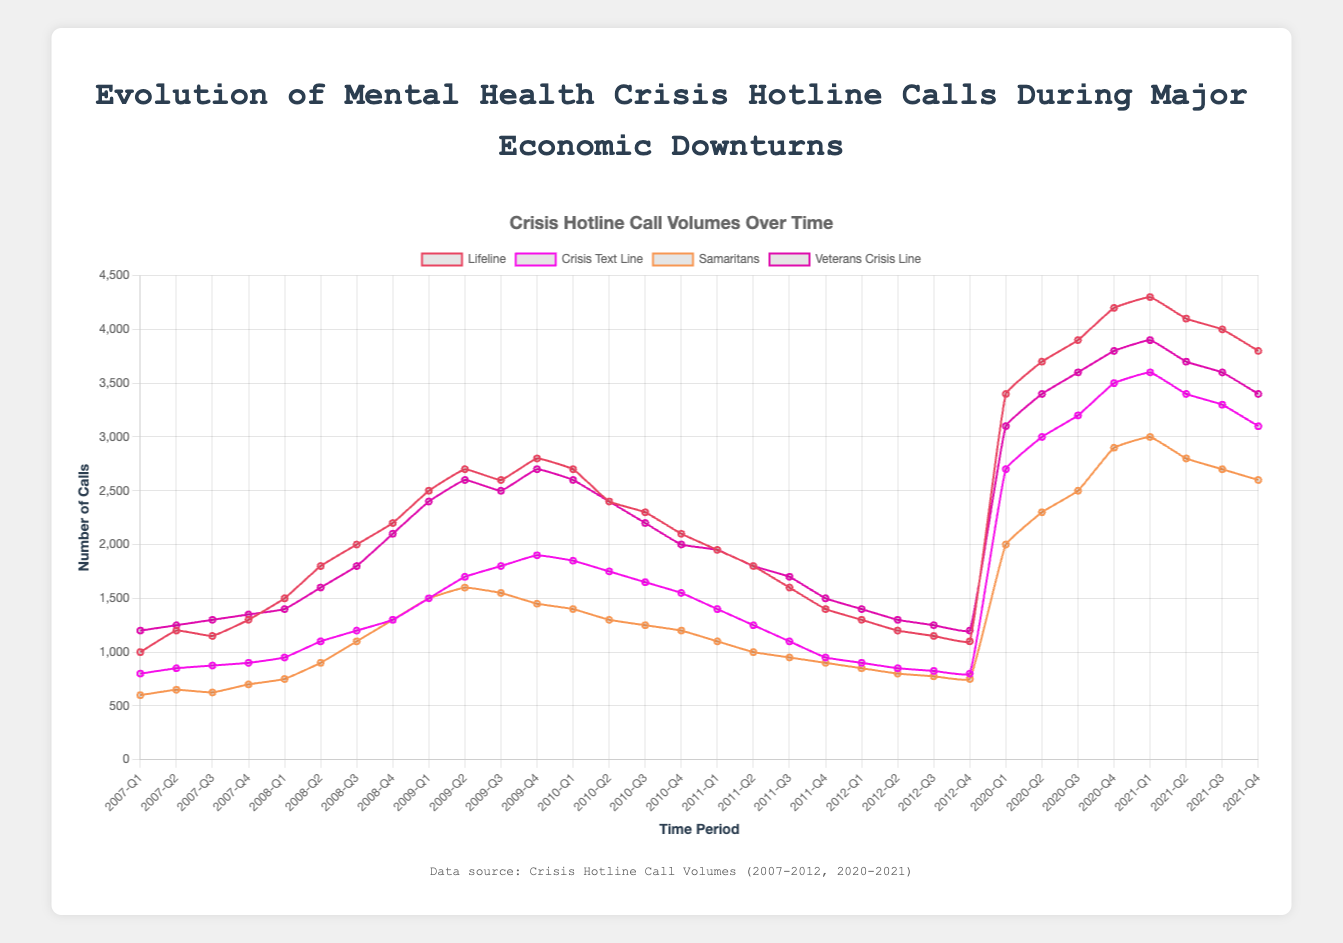How many total calls did Lifeline receive in 2009? Add the values for Lifeline in each quarter of 2009: 2500 (Q1) + 2700 (Q2) + 2600 (Q3) + 2800 (Q4) = 10600
Answer: 10600 During which quarter did Veterans Crisis Line have the highest number of calls? Find the highest point on the Veterans Crisis Line's line, which is in 2021-Q1 with 3900 calls
Answer: 2021-Q1 Compare the peak calls in 2008 for Lifeline and Samaritans. Which received more calls and by how much? Lifeline peak: 2200 (Q4), Samaritans peak: 1300 (Q4); Lifeline received 2200 - 1300 = 900 more calls
Answer: Lifeline by 900 Which crisis hotline saw the largest increase in calls from Q4 of 2012 to Q1 of 2020? Lifeline: 3400 - 1100 = 2300, Crisis Text Line: 2700 - 800 = 1900, Samaritans: 2000 - 750 = 1250, Veterans Crisis Line: 3100 - 1200 = 1900; Lifeline saw the largest increase of 2300 calls
Answer: Lifeline What is the average number of calls received by Crisis Text Line in 2020? Add calls for Crisis Text Line in 2020: 2700 (Q1) + 3000 (Q2) + 3200 (Q3) + 3500 (Q4) = 12400; average is 12400 / 4 = 3100
Answer: 3100 At what points did Veterans Crisis Line and Samaritans have the same number of calls? Find visually where their lines intersect: 2008-Q4 with 1300 calls; 2009-Q1 with 1500 calls
Answer: 2008-Q4, 2009-Q1 What was the total number of calls received by all hotlines at their lowest point between 2007 and 2012? Identifying the lowest points: Lifeline (1000, Q1 2007), Crisis Text Line (800, Q1 2007 & Q4 2012), Samaritans (600, Q1 2007), Veterans Crisis Line (1200, Q1 2007); total calls sum = 3600
Answer: 3600 Which crisis hotline had the steepest decline in calls after reaching its peak in 2009? Compare each drop: Lifeline from 2800 to 1400 = 1400 (-50%), Crisis Text Line from 1900 to 950 = 950 (-50%), Samaritans from 1600 to 900 = 700 (-43.75%), Veterans Crisis Line from 2700 to 1500 = 1200 (-44.44%); Lifeline and Crisis Text Line have the steepest decline
Answer: Lifeline, Crisis Text Line Which crisis hotline showed a consistent upward trend without any declines during 2007-2009? Check for unbroken upward trends visually: Samaritans rose from 600 to 1500 continuously from 2007-Q1 to 2009-Q2
Answer: Samaritans 